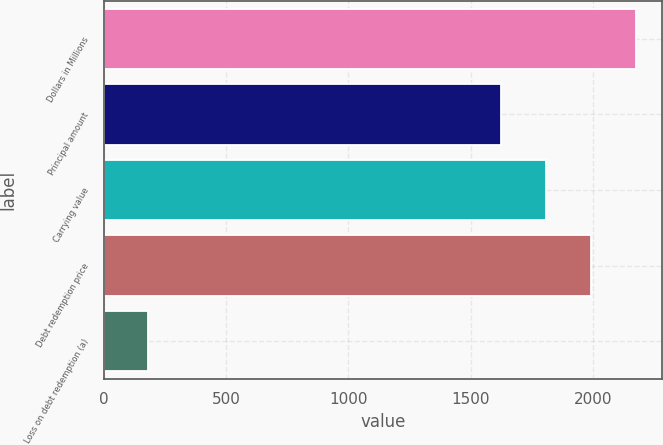Convert chart. <chart><loc_0><loc_0><loc_500><loc_500><bar_chart><fcel>Dollars in Millions<fcel>Principal amount<fcel>Carrying value<fcel>Debt redemption price<fcel>Loss on debt redemption (a)<nl><fcel>2174.5<fcel>1624<fcel>1807.5<fcel>1991<fcel>180<nl></chart> 